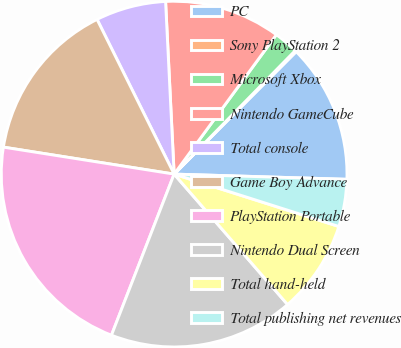<chart> <loc_0><loc_0><loc_500><loc_500><pie_chart><fcel>PC<fcel>Sony PlayStation 2<fcel>Microsoft Xbox<fcel>Nintendo GameCube<fcel>Total console<fcel>Game Boy Advance<fcel>PlayStation Portable<fcel>Nintendo Dual Screen<fcel>Total hand-held<fcel>Total publishing net revenues<nl><fcel>13.01%<fcel>0.13%<fcel>2.27%<fcel>10.86%<fcel>6.57%<fcel>15.15%<fcel>21.59%<fcel>17.3%<fcel>8.71%<fcel>4.42%<nl></chart> 